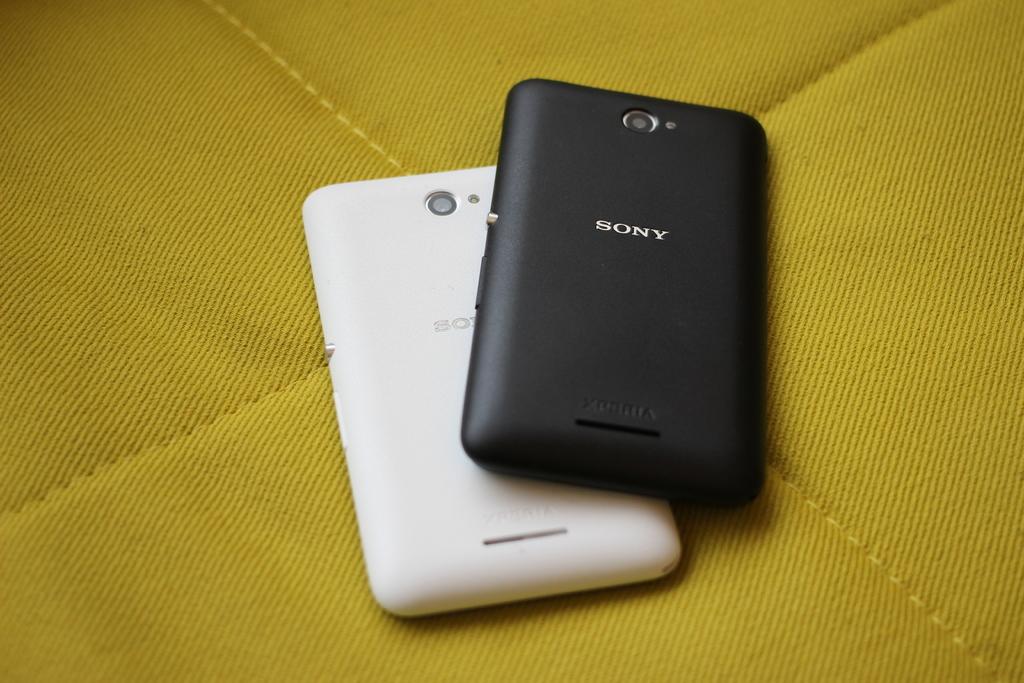What brand is the black phone?
Provide a succinct answer. Sony. 